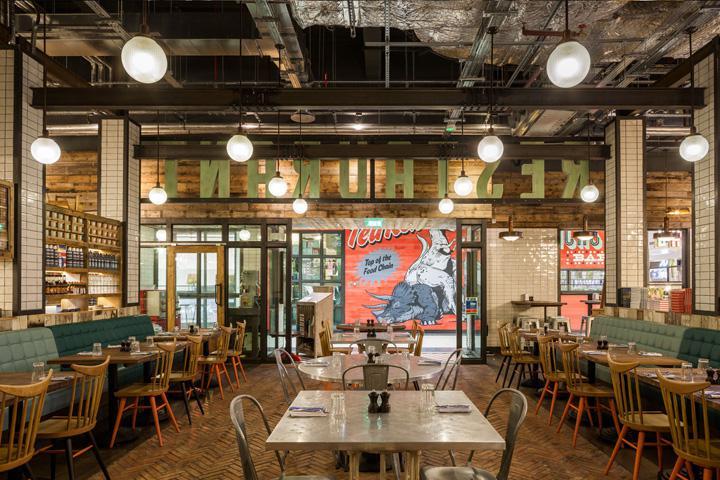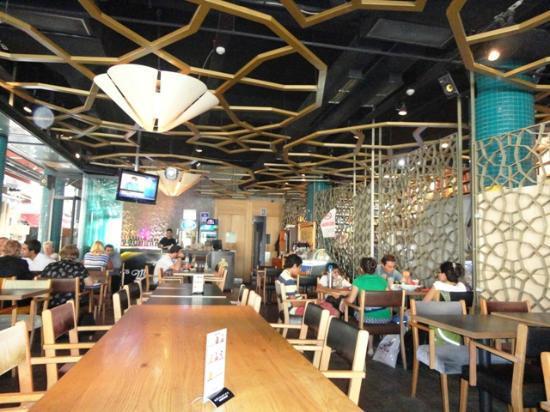The first image is the image on the left, the second image is the image on the right. Evaluate the accuracy of this statement regarding the images: "The right image shows the interior of a restaurant with cone-shaped light fixtures on a ceiling with suspended circles containing geometric patterns that repeat on the right wall.". Is it true? Answer yes or no. Yes. 